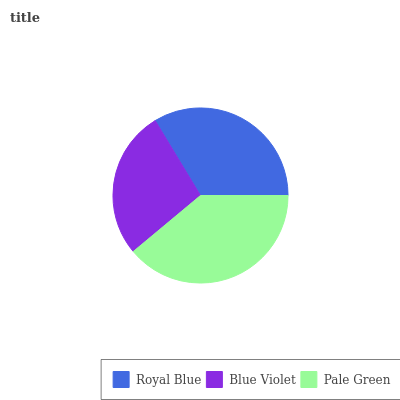Is Blue Violet the minimum?
Answer yes or no. Yes. Is Pale Green the maximum?
Answer yes or no. Yes. Is Pale Green the minimum?
Answer yes or no. No. Is Blue Violet the maximum?
Answer yes or no. No. Is Pale Green greater than Blue Violet?
Answer yes or no. Yes. Is Blue Violet less than Pale Green?
Answer yes or no. Yes. Is Blue Violet greater than Pale Green?
Answer yes or no. No. Is Pale Green less than Blue Violet?
Answer yes or no. No. Is Royal Blue the high median?
Answer yes or no. Yes. Is Royal Blue the low median?
Answer yes or no. Yes. Is Blue Violet the high median?
Answer yes or no. No. Is Blue Violet the low median?
Answer yes or no. No. 